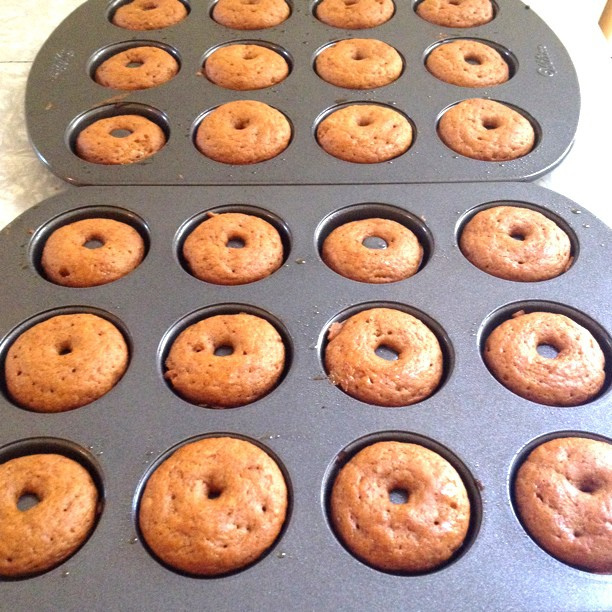What are these items in the baking tray? The items in the baking tray appear to be freshly baked donuts.  Can you tell the number of donuts baked here? Yes, there are 24 donuts in the baking tray. 